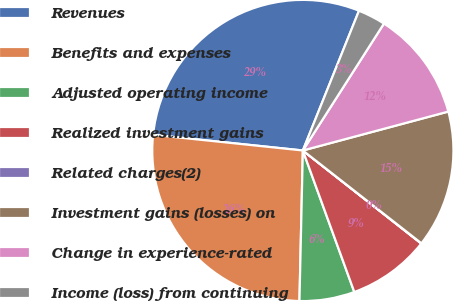Convert chart to OTSL. <chart><loc_0><loc_0><loc_500><loc_500><pie_chart><fcel>Revenues<fcel>Benefits and expenses<fcel>Adjusted operating income<fcel>Realized investment gains<fcel>Related charges(2)<fcel>Investment gains (losses) on<fcel>Change in experience-rated<fcel>Income (loss) from continuing<nl><fcel>29.42%<fcel>26.3%<fcel>5.91%<fcel>8.85%<fcel>0.03%<fcel>14.73%<fcel>11.79%<fcel>2.97%<nl></chart> 